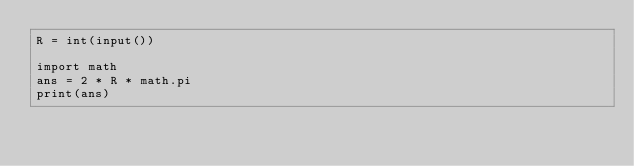Convert code to text. <code><loc_0><loc_0><loc_500><loc_500><_Python_>R = int(input())

import math
ans = 2 * R * math.pi
print(ans)</code> 